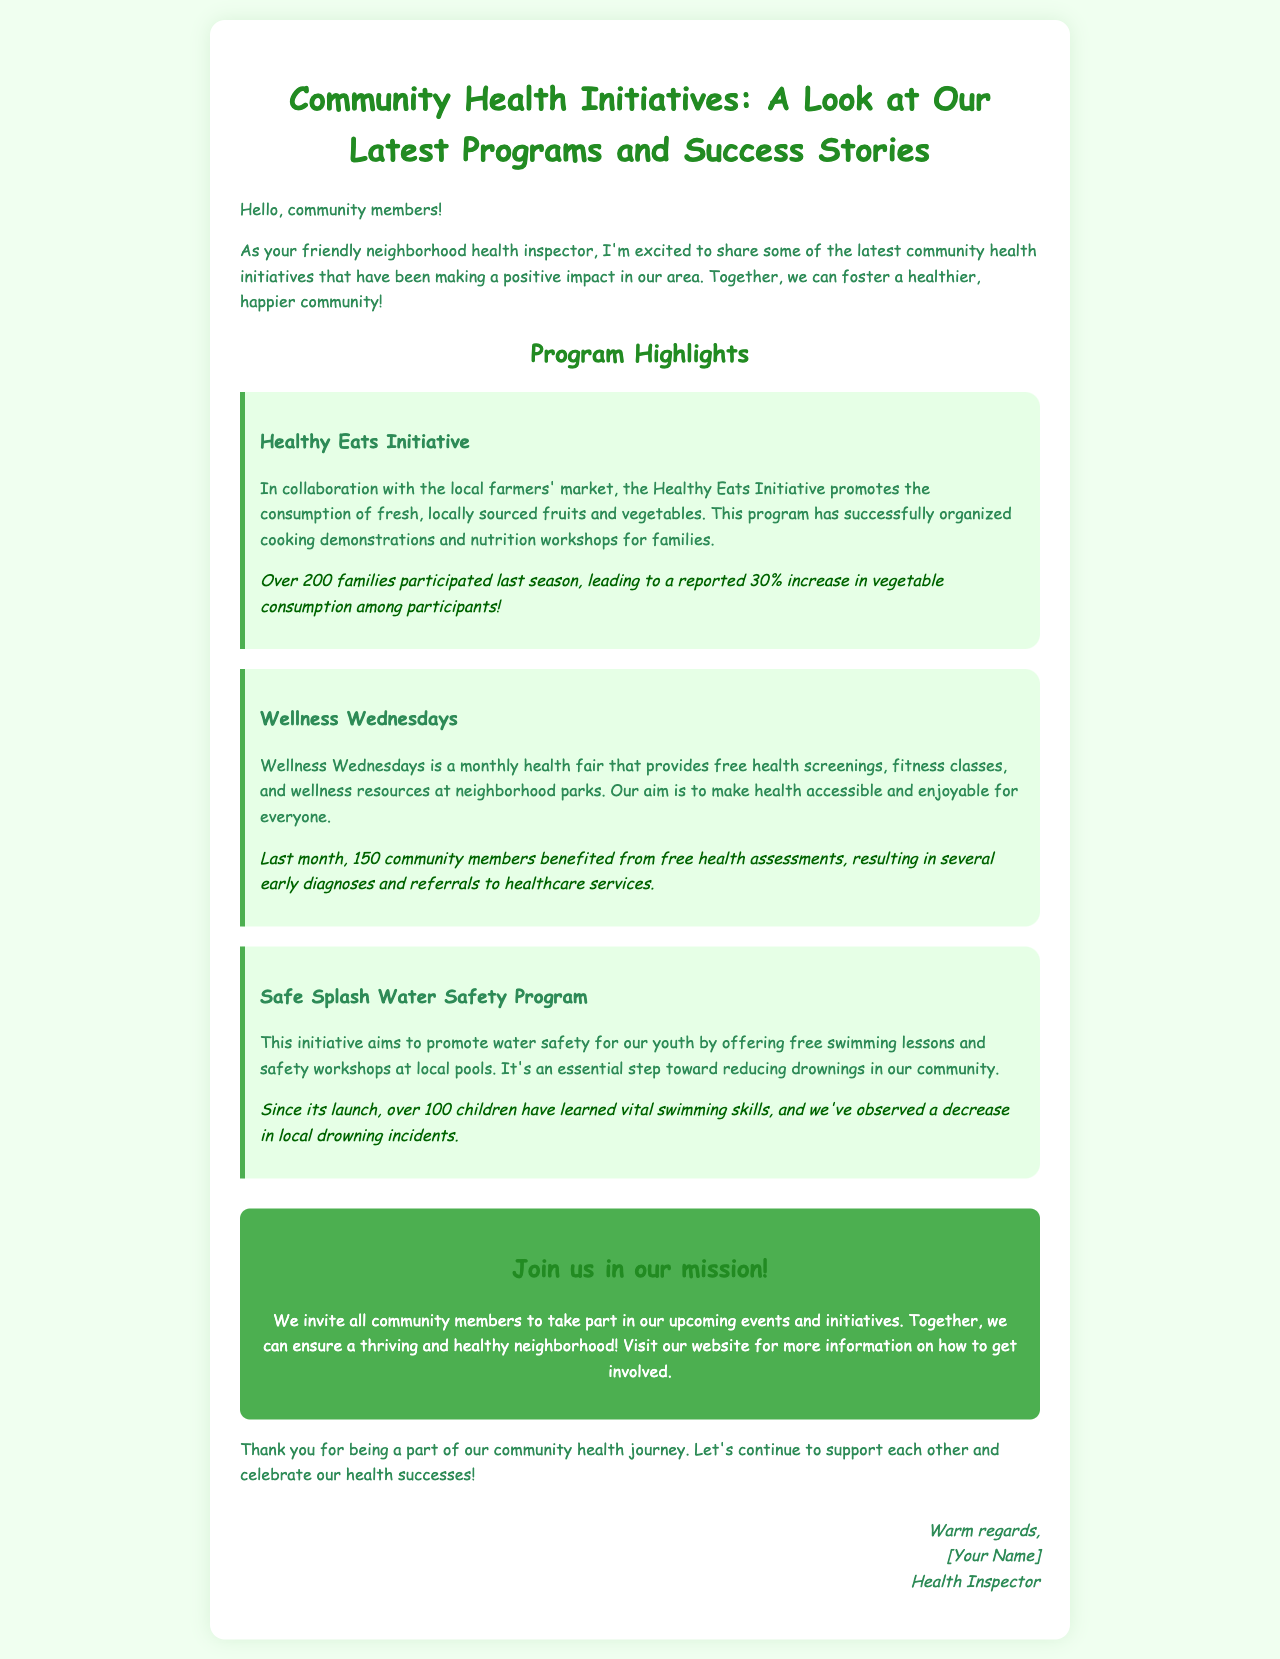What is the name of the initiative promoting consumption of fruits and vegetables? The initiative is highlighted in the document as promoting fresh produce, specifically focusing on local sources.
Answer: Healthy Eats Initiative How many families participated in the Healthy Eats Initiative last season? The participation number is specifically stated for this program, showcasing community involvement.
Answer: Over 200 families What is the main focus of Wellness Wednesdays? The document describes the purpose of this monthly event, catering to the community's health needs.
Answer: Free health screenings How many community members benefitted from the last Wellness Wednesdays event? The specific number of individuals who received free health assessments is mentioned in the document.
Answer: 150 community members What is the primary goal of the Safe Splash Water Safety Program? The document outlines the aim of this initiative, which is centered around youth safety in water.
Answer: Promote water safety Since its launch, how many children have learned vital swimming skills through the Safe Splash Program? The document provides a figure representing the impact of this water safety initiative on children.
Answer: Over 100 children What is the call to action presented in the document? The document encourages community members to engage with upcoming events, fostering health initiatives.
Answer: Join us in our mission! What type of health services does Wellness Wednesdays provide? The document lists the type of resources made available during this community-focused event.
Answer: Wellness resources Who is the author of the newsletter? The document includes a section where the author's name and title is mentioned.
Answer: [Your Name] 